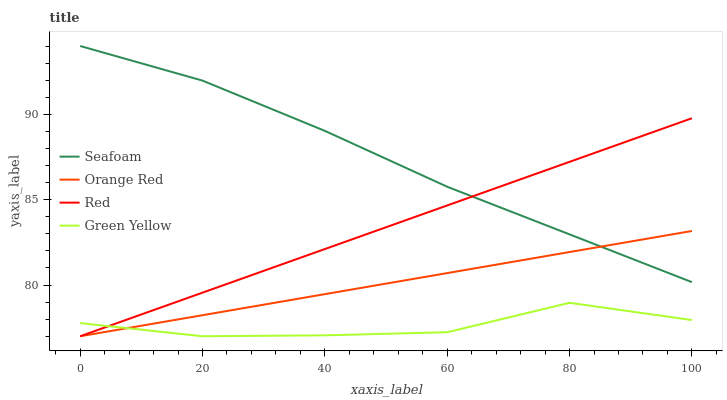Does Red have the minimum area under the curve?
Answer yes or no. No. Does Red have the maximum area under the curve?
Answer yes or no. No. Is Seafoam the smoothest?
Answer yes or no. No. Is Seafoam the roughest?
Answer yes or no. No. Does Seafoam have the lowest value?
Answer yes or no. No. Does Red have the highest value?
Answer yes or no. No. Is Green Yellow less than Seafoam?
Answer yes or no. Yes. Is Seafoam greater than Green Yellow?
Answer yes or no. Yes. Does Green Yellow intersect Seafoam?
Answer yes or no. No. 